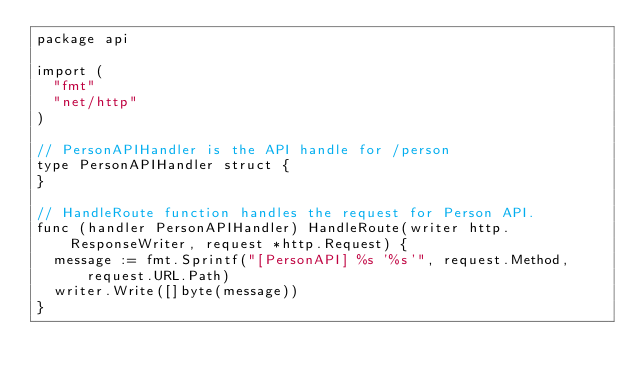Convert code to text. <code><loc_0><loc_0><loc_500><loc_500><_Go_>package api

import (
	"fmt"
	"net/http"
)

// PersonAPIHandler is the API handle for /person
type PersonAPIHandler struct {
}

// HandleRoute function handles the request for Person API.
func (handler PersonAPIHandler) HandleRoute(writer http.ResponseWriter, request *http.Request) {
	message := fmt.Sprintf("[PersonAPI] %s '%s'", request.Method, request.URL.Path)
	writer.Write([]byte(message))
}
</code> 